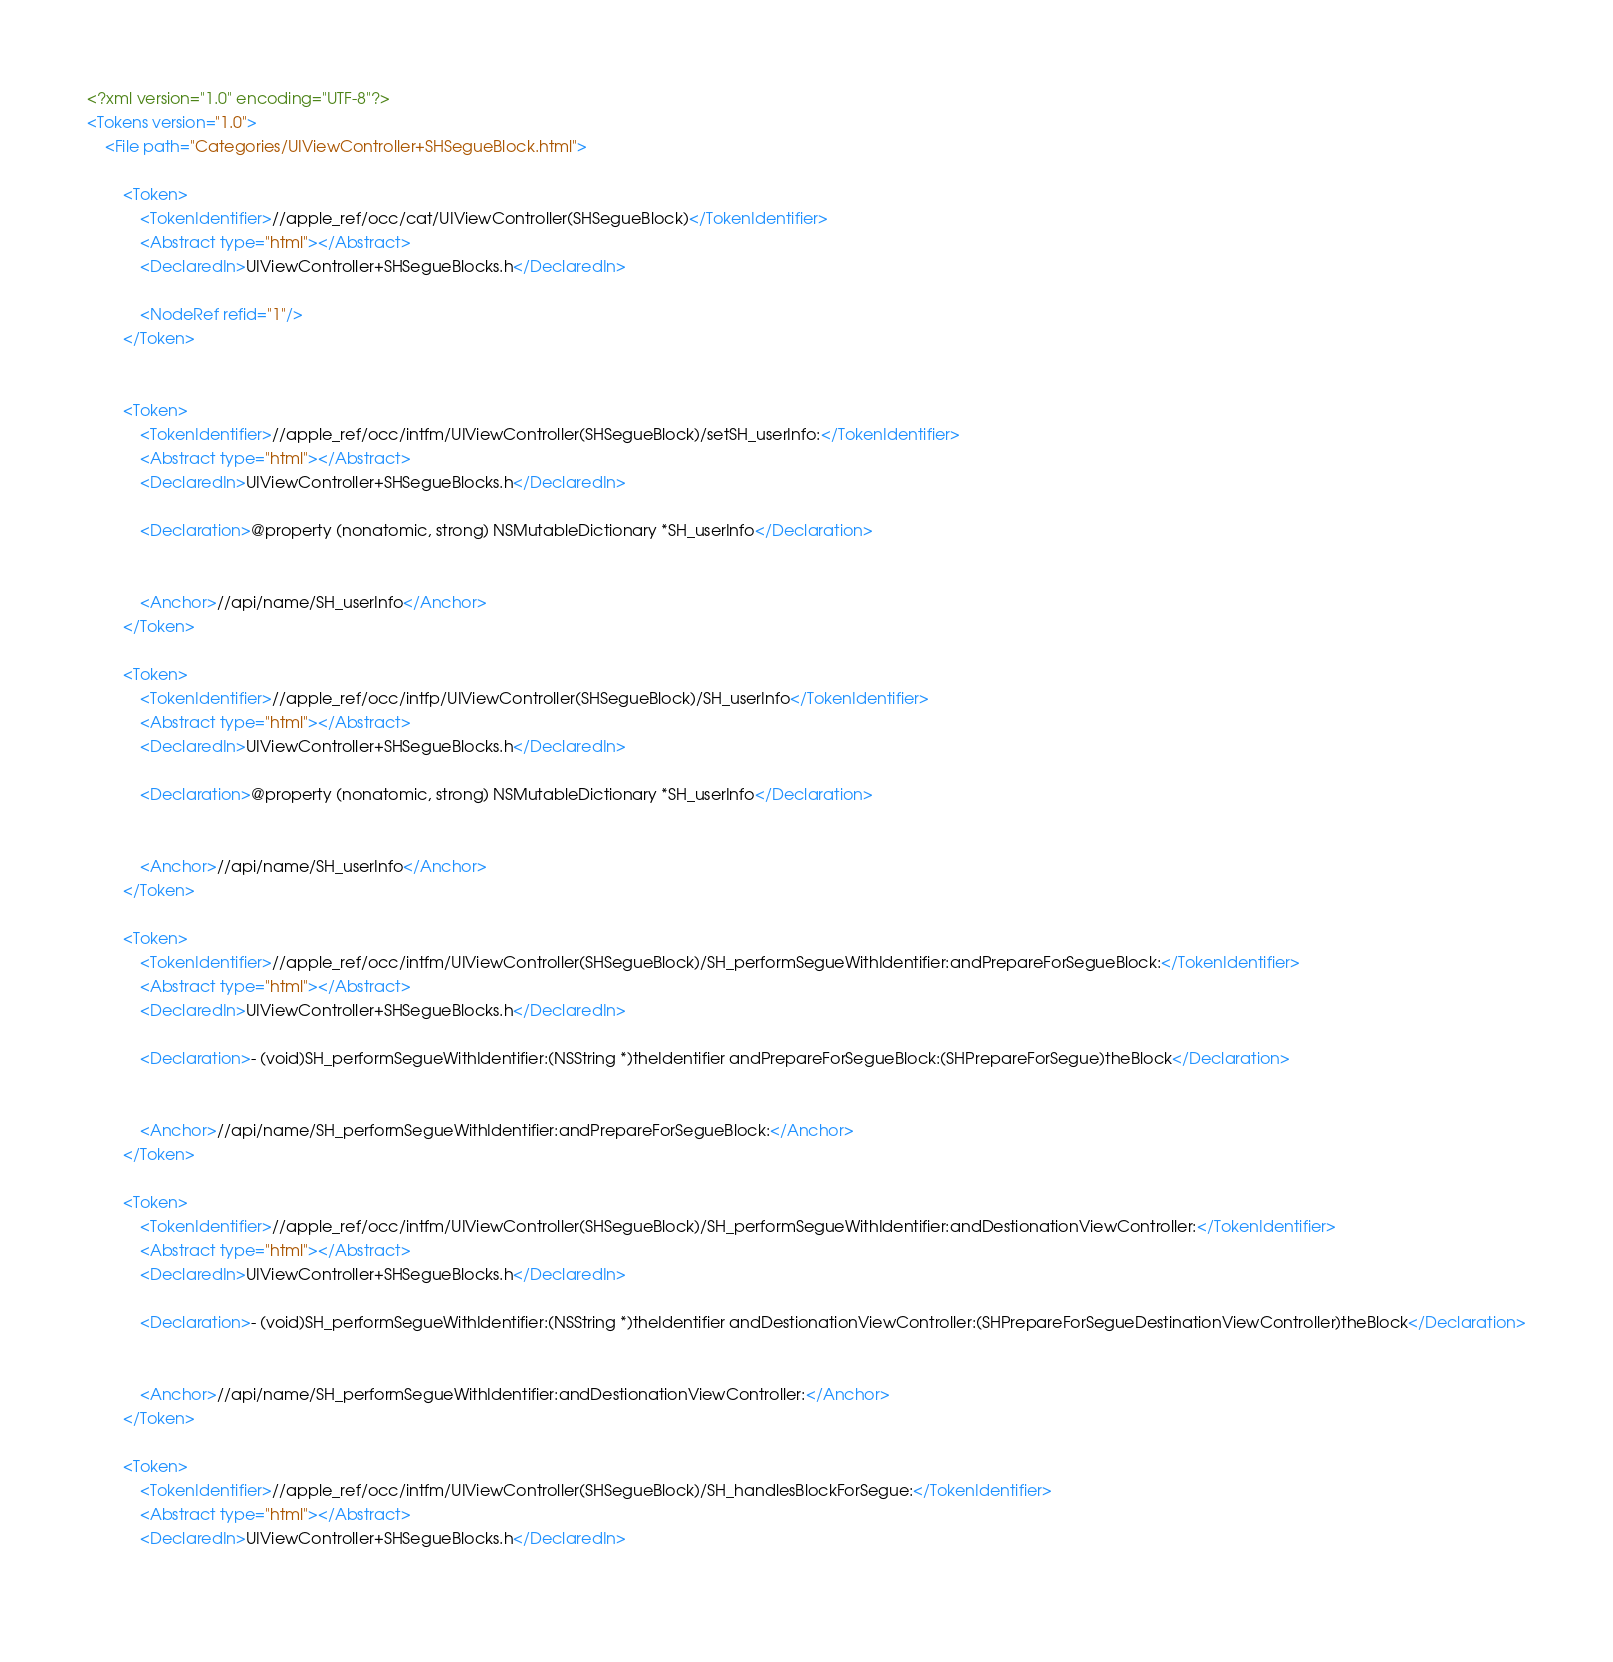Convert code to text. <code><loc_0><loc_0><loc_500><loc_500><_XML_><?xml version="1.0" encoding="UTF-8"?>
<Tokens version="1.0">
	<File path="Categories/UIViewController+SHSegueBlock.html">
		
		<Token>
			<TokenIdentifier>//apple_ref/occ/cat/UIViewController(SHSegueBlock)</TokenIdentifier>
			<Abstract type="html"></Abstract>
			<DeclaredIn>UIViewController+SHSegueBlocks.h</DeclaredIn>
			
			<NodeRef refid="1"/>
		</Token>
		
		
		<Token>
			<TokenIdentifier>//apple_ref/occ/intfm/UIViewController(SHSegueBlock)/setSH_userInfo:</TokenIdentifier>
			<Abstract type="html"></Abstract>
			<DeclaredIn>UIViewController+SHSegueBlocks.h</DeclaredIn>			
			
			<Declaration>@property (nonatomic, strong) NSMutableDictionary *SH_userInfo</Declaration>
			
			
			<Anchor>//api/name/SH_userInfo</Anchor>
		</Token>
		
		<Token>
			<TokenIdentifier>//apple_ref/occ/intfp/UIViewController(SHSegueBlock)/SH_userInfo</TokenIdentifier>
			<Abstract type="html"></Abstract>
			<DeclaredIn>UIViewController+SHSegueBlocks.h</DeclaredIn>			
			
			<Declaration>@property (nonatomic, strong) NSMutableDictionary *SH_userInfo</Declaration>
			
			
			<Anchor>//api/name/SH_userInfo</Anchor>
		</Token>
		
		<Token>
			<TokenIdentifier>//apple_ref/occ/intfm/UIViewController(SHSegueBlock)/SH_performSegueWithIdentifier:andPrepareForSegueBlock:</TokenIdentifier>
			<Abstract type="html"></Abstract>
			<DeclaredIn>UIViewController+SHSegueBlocks.h</DeclaredIn>			
			
			<Declaration>- (void)SH_performSegueWithIdentifier:(NSString *)theIdentifier andPrepareForSegueBlock:(SHPrepareForSegue)theBlock</Declaration>
			
			
			<Anchor>//api/name/SH_performSegueWithIdentifier:andPrepareForSegueBlock:</Anchor>
		</Token>
		
		<Token>
			<TokenIdentifier>//apple_ref/occ/intfm/UIViewController(SHSegueBlock)/SH_performSegueWithIdentifier:andDestionationViewController:</TokenIdentifier>
			<Abstract type="html"></Abstract>
			<DeclaredIn>UIViewController+SHSegueBlocks.h</DeclaredIn>			
			
			<Declaration>- (void)SH_performSegueWithIdentifier:(NSString *)theIdentifier andDestionationViewController:(SHPrepareForSegueDestinationViewController)theBlock</Declaration>
			
			
			<Anchor>//api/name/SH_performSegueWithIdentifier:andDestionationViewController:</Anchor>
		</Token>
		
		<Token>
			<TokenIdentifier>//apple_ref/occ/intfm/UIViewController(SHSegueBlock)/SH_handlesBlockForSegue:</TokenIdentifier>
			<Abstract type="html"></Abstract>
			<DeclaredIn>UIViewController+SHSegueBlocks.h</DeclaredIn>			
			</code> 